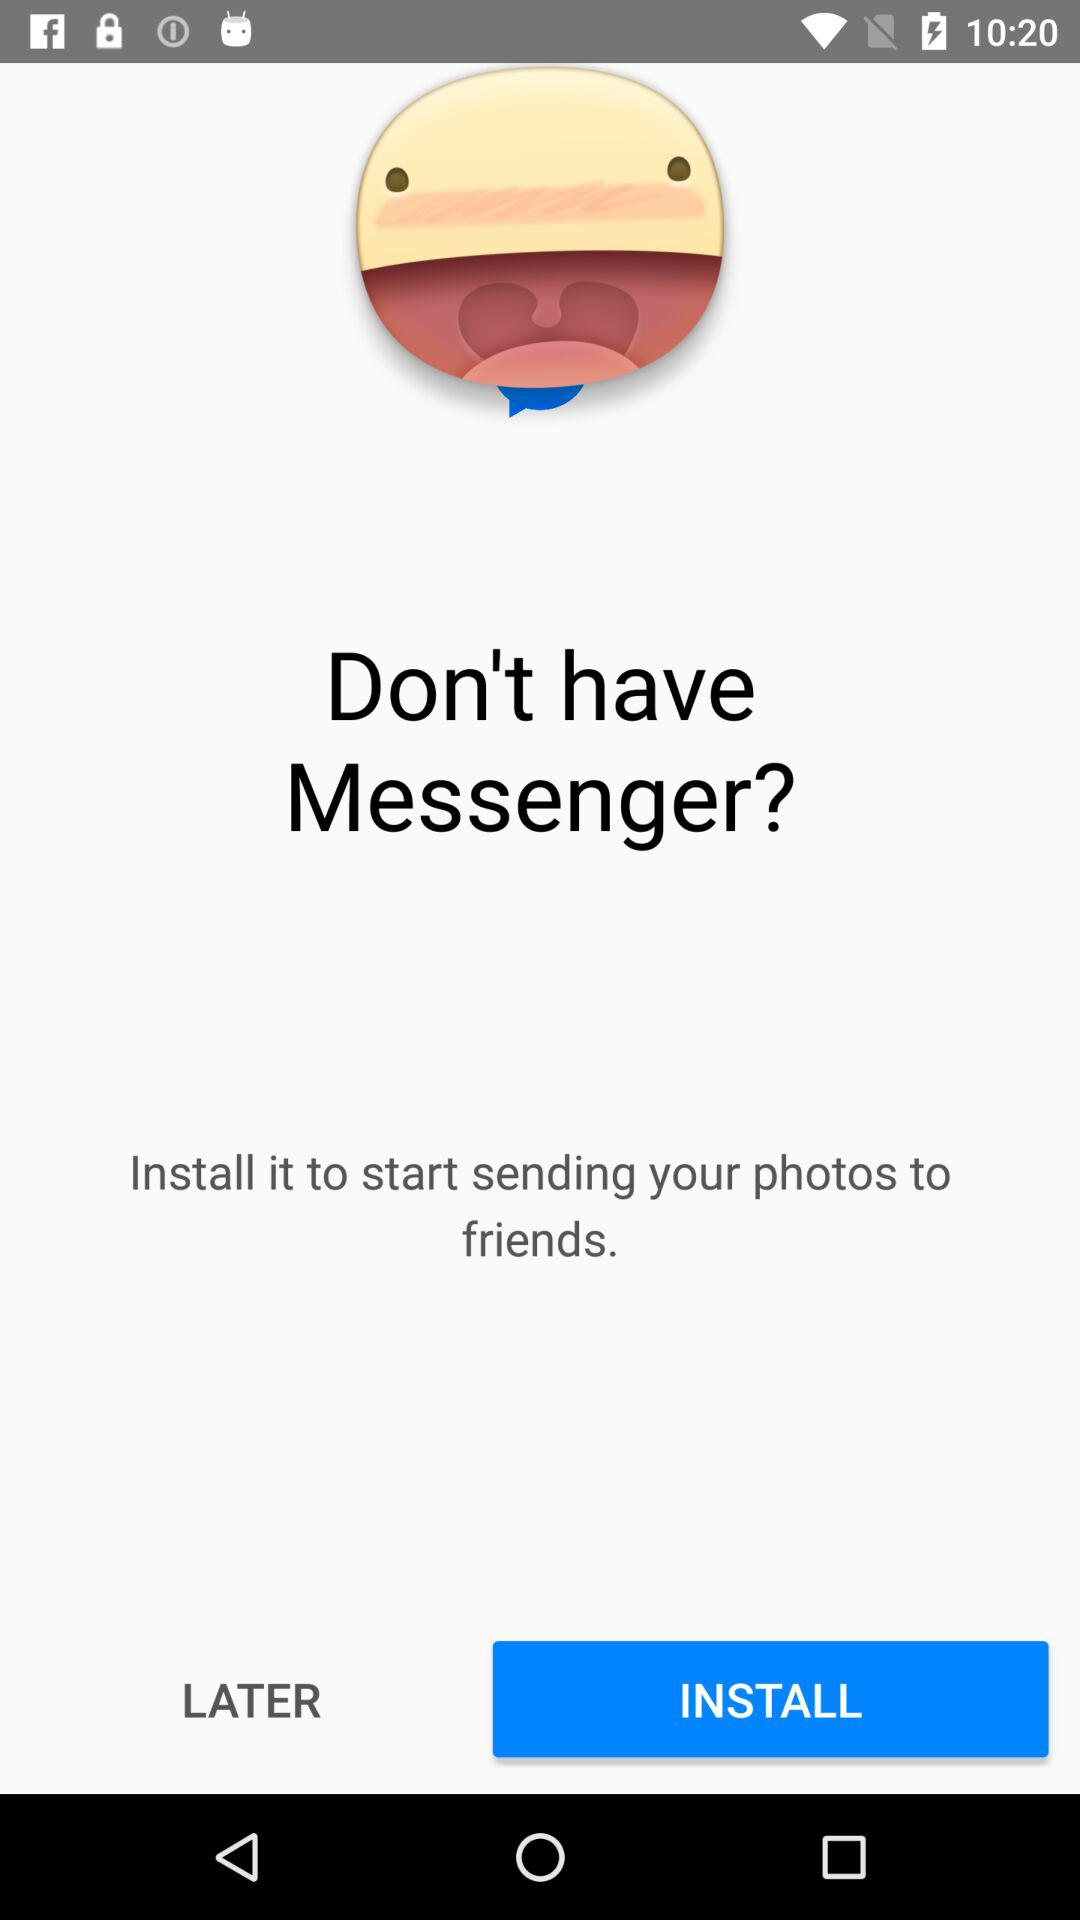How many messages are in "Messenger"?
When the provided information is insufficient, respond with <no answer>. <no answer> 